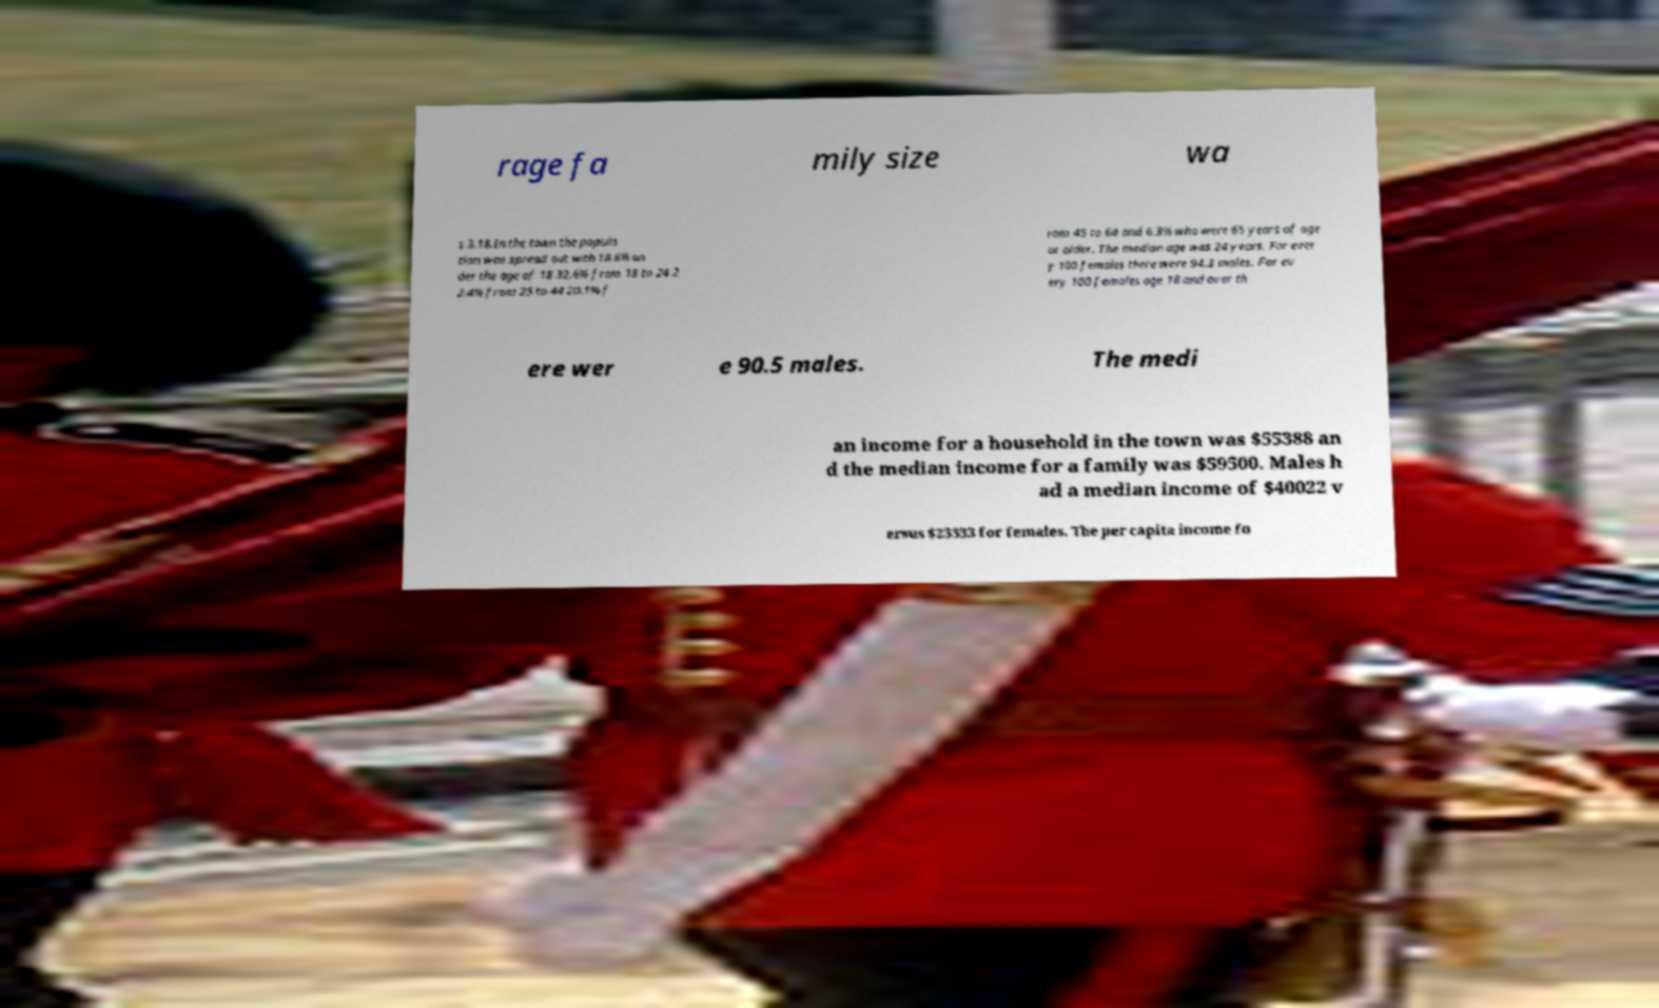Could you assist in decoding the text presented in this image and type it out clearly? rage fa mily size wa s 3.18.In the town the popula tion was spread out with 18.6% un der the age of 18 32.6% from 18 to 24 2 2.4% from 25 to 44 20.1% f rom 45 to 64 and 6.3% who were 65 years of age or older. The median age was 24 years. For ever y 100 females there were 94.3 males. For ev ery 100 females age 18 and over th ere wer e 90.5 males. The medi an income for a household in the town was $55388 an d the median income for a family was $59500. Males h ad a median income of $40022 v ersus $23333 for females. The per capita income fo 